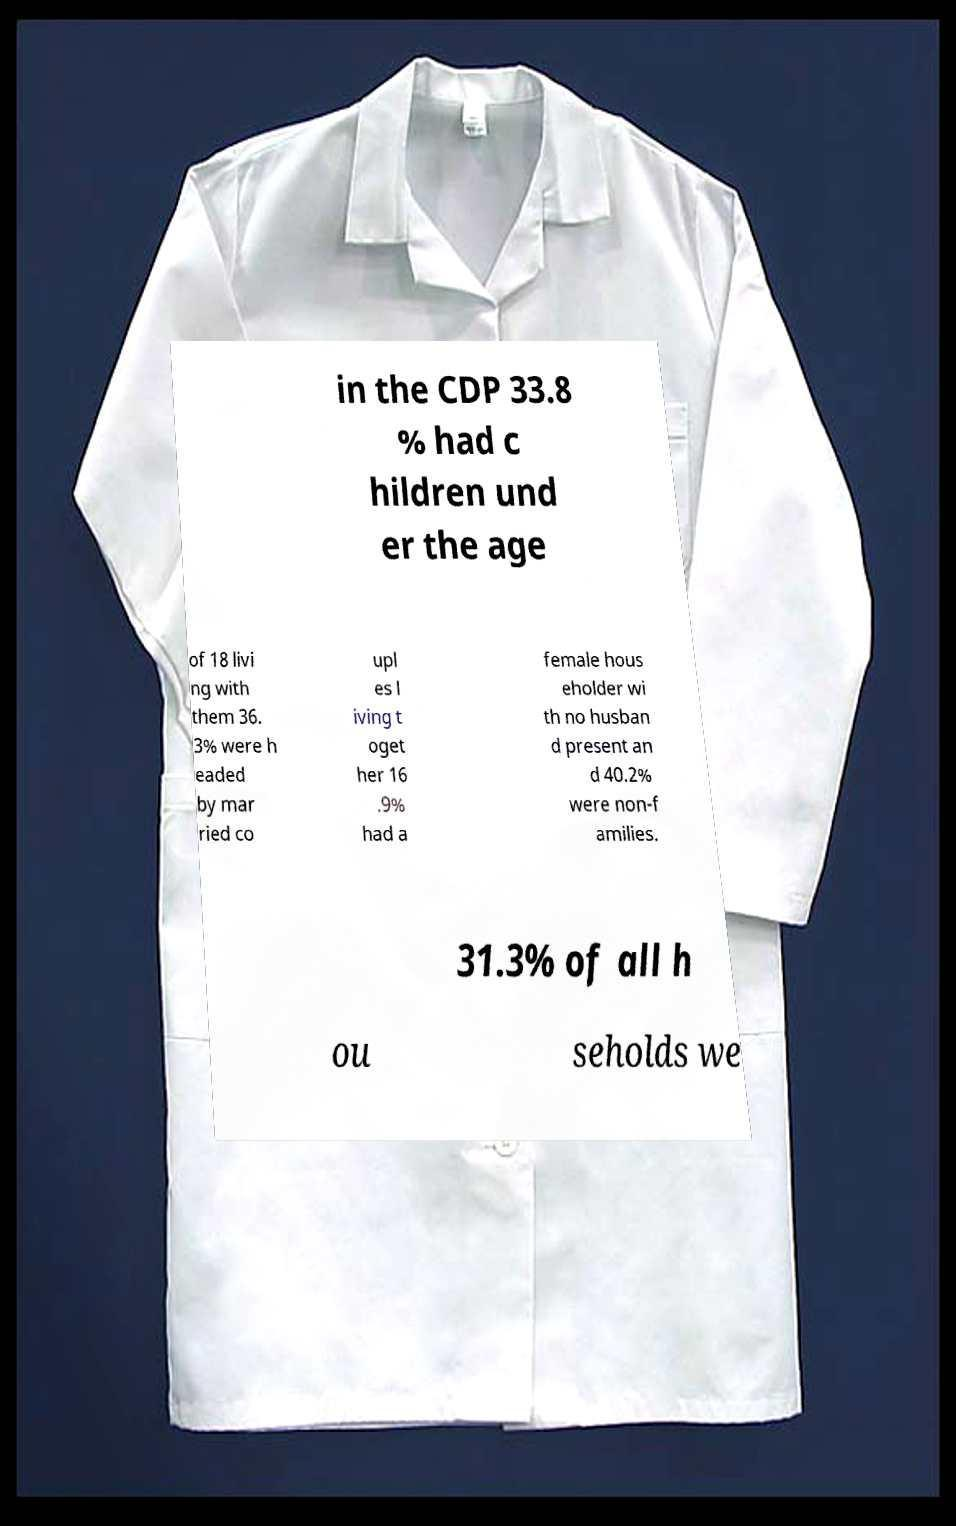For documentation purposes, I need the text within this image transcribed. Could you provide that? in the CDP 33.8 % had c hildren und er the age of 18 livi ng with them 36. 3% were h eaded by mar ried co upl es l iving t oget her 16 .9% had a female hous eholder wi th no husban d present an d 40.2% were non-f amilies. 31.3% of all h ou seholds we 